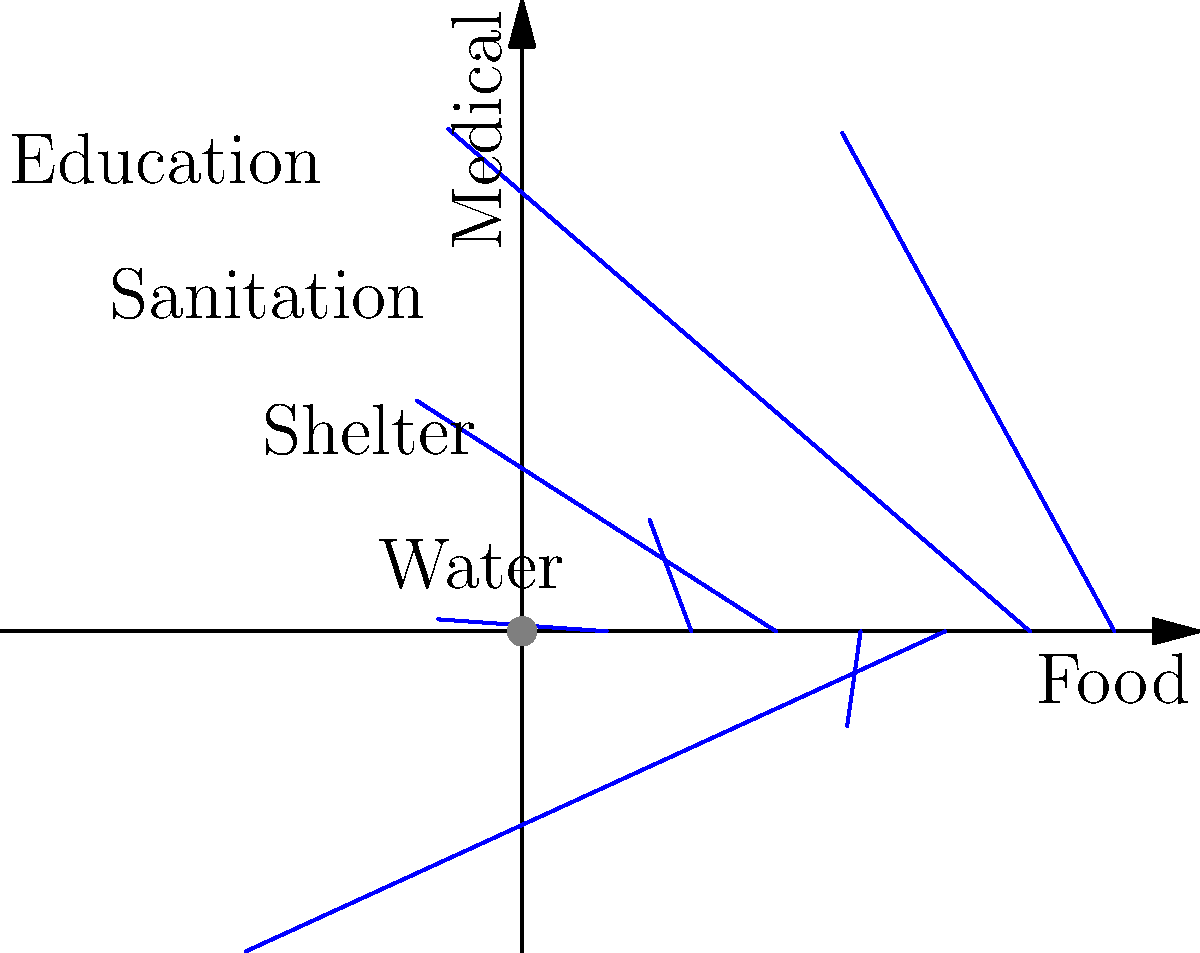The polar plot above represents the distribution of aid resources in a conflict zone. Each spoke represents a different type of aid, and the length of each spoke indicates the relative amount of resources allocated. Based on this plot, which two types of aid have the highest and lowest resource allocation, respectively? To answer this question, we need to analyze the polar plot and compare the lengths of each spoke:

1. Identify the aid types:
   - 0° (right): Food
   - 45° (top-right): Water
   - 90° (top): Medical
   - 135° (top-left): Shelter
   - 180° (left): Sanitation
   - 225° (bottom-left): Unlabeled
   - 270° (bottom): Education
   - 315° (bottom-right): Unlabeled

2. Compare the lengths of the spokes:
   - Food: 5 units
   - Water: 3 units
   - Medical: 7 units
   - Shelter: 2 units
   - Sanitation: 6 units
   - Unlabeled (225°): 4 units
   - Education: 8 units
   - Unlabeled (315°): 1 unit

3. Identify the highest allocation:
   Education has the longest spoke at 8 units.

4. Identify the lowest allocation:
   The unlabeled spoke at 315° has the shortest length at 1 unit.

Therefore, Education has the highest resource allocation, while the unlabeled aid type at 315° has the lowest.
Answer: Highest: Education; Lowest: Unlabeled aid at 315° 